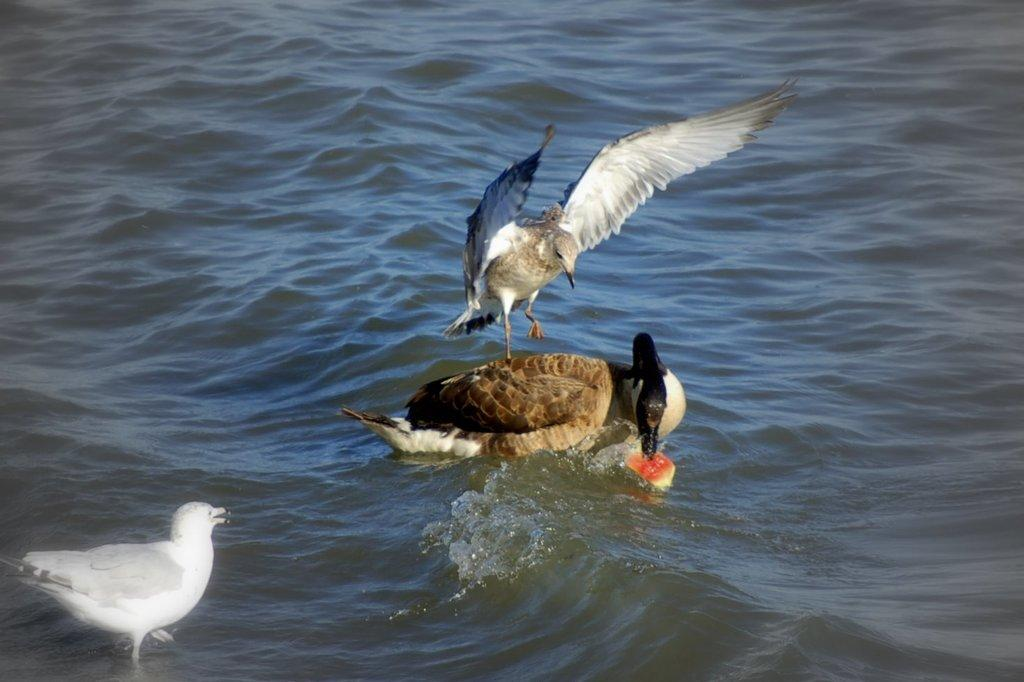What type of animals can be seen in the image? Birds can be seen in the image. What is the primary element in which the birds are situated? The birds are situated in water. Can you describe the object in the image? Unfortunately, the facts provided do not give any details about the object in the image. How much money is floating in the water in the image? There is no money visible in the image; it only features birds and water. 